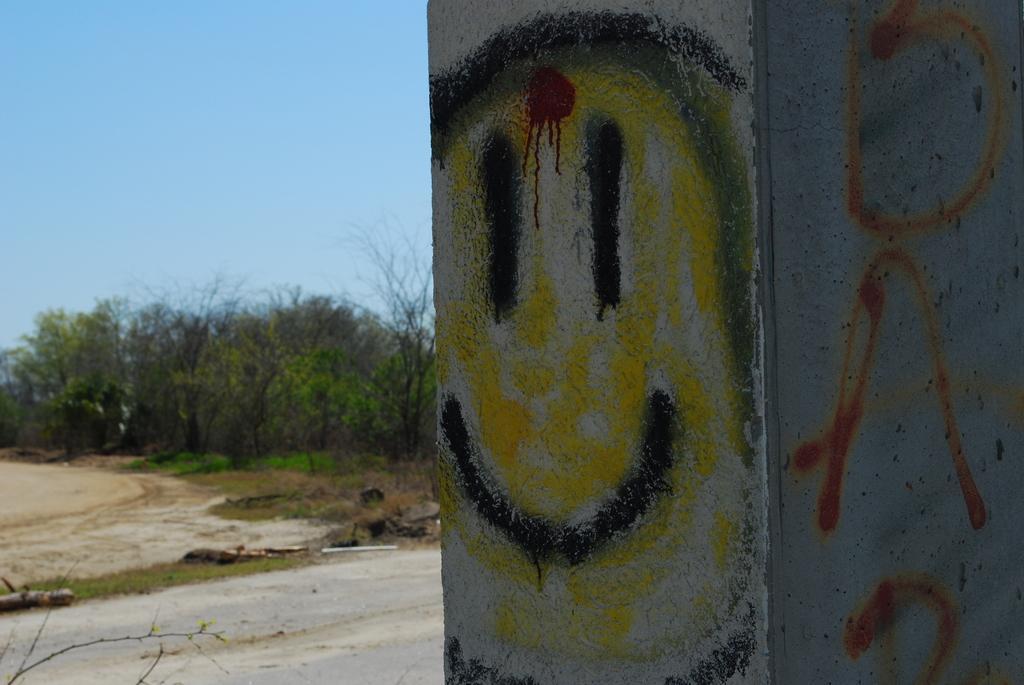Can you describe this image briefly? On the right side of the image there is a wall, on the left side of the image there are some trees. At the top of the image there is sky. 